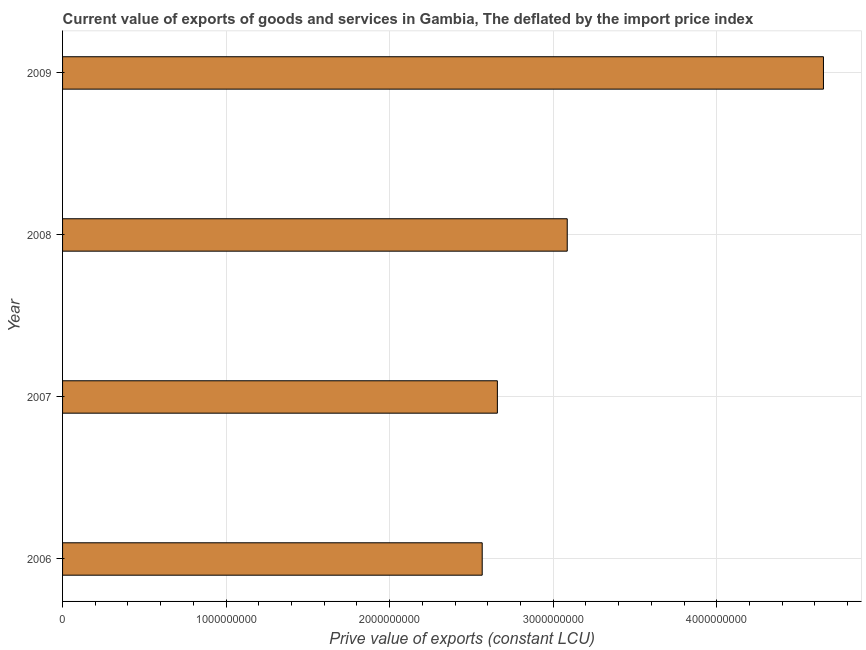Does the graph contain any zero values?
Offer a very short reply. No. Does the graph contain grids?
Provide a succinct answer. Yes. What is the title of the graph?
Your answer should be very brief. Current value of exports of goods and services in Gambia, The deflated by the import price index. What is the label or title of the X-axis?
Provide a short and direct response. Prive value of exports (constant LCU). What is the price value of exports in 2007?
Your answer should be very brief. 2.66e+09. Across all years, what is the maximum price value of exports?
Offer a terse response. 4.65e+09. Across all years, what is the minimum price value of exports?
Provide a succinct answer. 2.57e+09. What is the sum of the price value of exports?
Your answer should be very brief. 1.30e+1. What is the difference between the price value of exports in 2006 and 2008?
Give a very brief answer. -5.20e+08. What is the average price value of exports per year?
Your answer should be very brief. 3.24e+09. What is the median price value of exports?
Your answer should be very brief. 2.87e+09. In how many years, is the price value of exports greater than 1600000000 LCU?
Ensure brevity in your answer.  4. Do a majority of the years between 2008 and 2007 (inclusive) have price value of exports greater than 3200000000 LCU?
Provide a succinct answer. No. What is the ratio of the price value of exports in 2007 to that in 2008?
Your answer should be compact. 0.86. Is the difference between the price value of exports in 2006 and 2007 greater than the difference between any two years?
Make the answer very short. No. What is the difference between the highest and the second highest price value of exports?
Ensure brevity in your answer.  1.57e+09. Is the sum of the price value of exports in 2007 and 2009 greater than the maximum price value of exports across all years?
Provide a short and direct response. Yes. What is the difference between the highest and the lowest price value of exports?
Make the answer very short. 2.09e+09. In how many years, is the price value of exports greater than the average price value of exports taken over all years?
Offer a very short reply. 1. Are the values on the major ticks of X-axis written in scientific E-notation?
Provide a short and direct response. No. What is the Prive value of exports (constant LCU) of 2006?
Offer a very short reply. 2.57e+09. What is the Prive value of exports (constant LCU) of 2007?
Give a very brief answer. 2.66e+09. What is the Prive value of exports (constant LCU) in 2008?
Give a very brief answer. 3.09e+09. What is the Prive value of exports (constant LCU) in 2009?
Offer a terse response. 4.65e+09. What is the difference between the Prive value of exports (constant LCU) in 2006 and 2007?
Provide a succinct answer. -9.28e+07. What is the difference between the Prive value of exports (constant LCU) in 2006 and 2008?
Ensure brevity in your answer.  -5.20e+08. What is the difference between the Prive value of exports (constant LCU) in 2006 and 2009?
Provide a short and direct response. -2.09e+09. What is the difference between the Prive value of exports (constant LCU) in 2007 and 2008?
Ensure brevity in your answer.  -4.27e+08. What is the difference between the Prive value of exports (constant LCU) in 2007 and 2009?
Offer a terse response. -1.99e+09. What is the difference between the Prive value of exports (constant LCU) in 2008 and 2009?
Offer a terse response. -1.57e+09. What is the ratio of the Prive value of exports (constant LCU) in 2006 to that in 2007?
Your answer should be compact. 0.96. What is the ratio of the Prive value of exports (constant LCU) in 2006 to that in 2008?
Provide a succinct answer. 0.83. What is the ratio of the Prive value of exports (constant LCU) in 2006 to that in 2009?
Provide a succinct answer. 0.55. What is the ratio of the Prive value of exports (constant LCU) in 2007 to that in 2008?
Your answer should be compact. 0.86. What is the ratio of the Prive value of exports (constant LCU) in 2007 to that in 2009?
Your answer should be compact. 0.57. What is the ratio of the Prive value of exports (constant LCU) in 2008 to that in 2009?
Offer a very short reply. 0.66. 